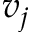Convert formula to latex. <formula><loc_0><loc_0><loc_500><loc_500>v _ { j }</formula> 